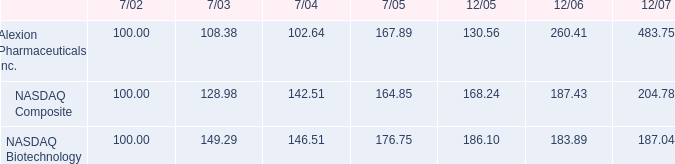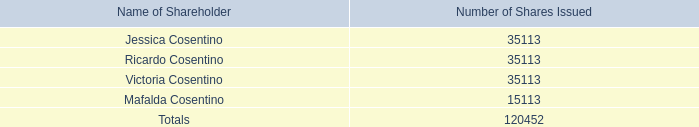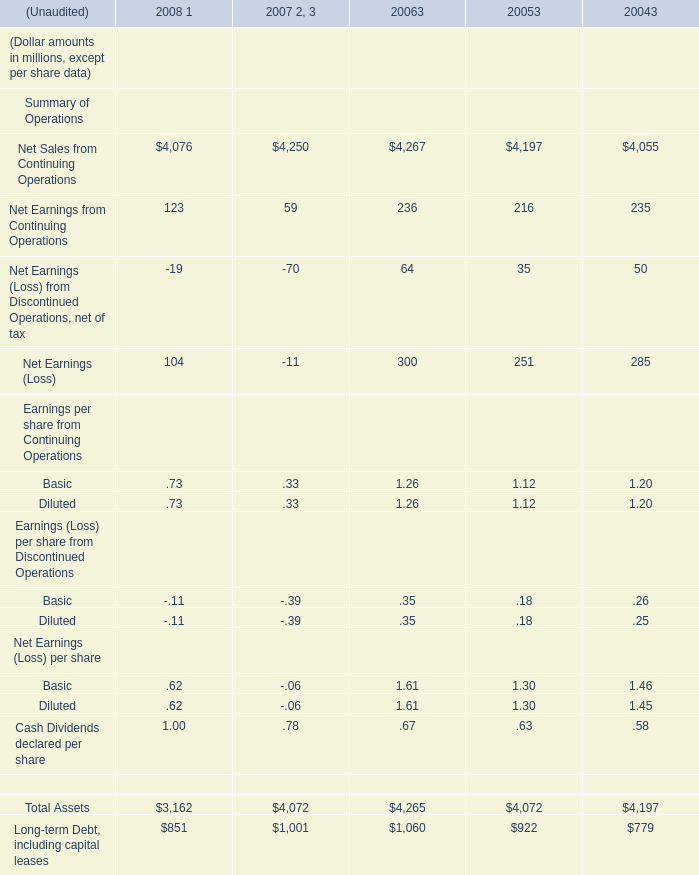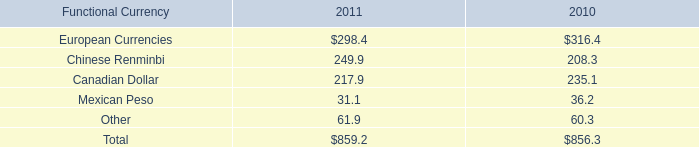When does Net Earnings from Continuing Operations reach the largest value? 
Answer: 2006. 